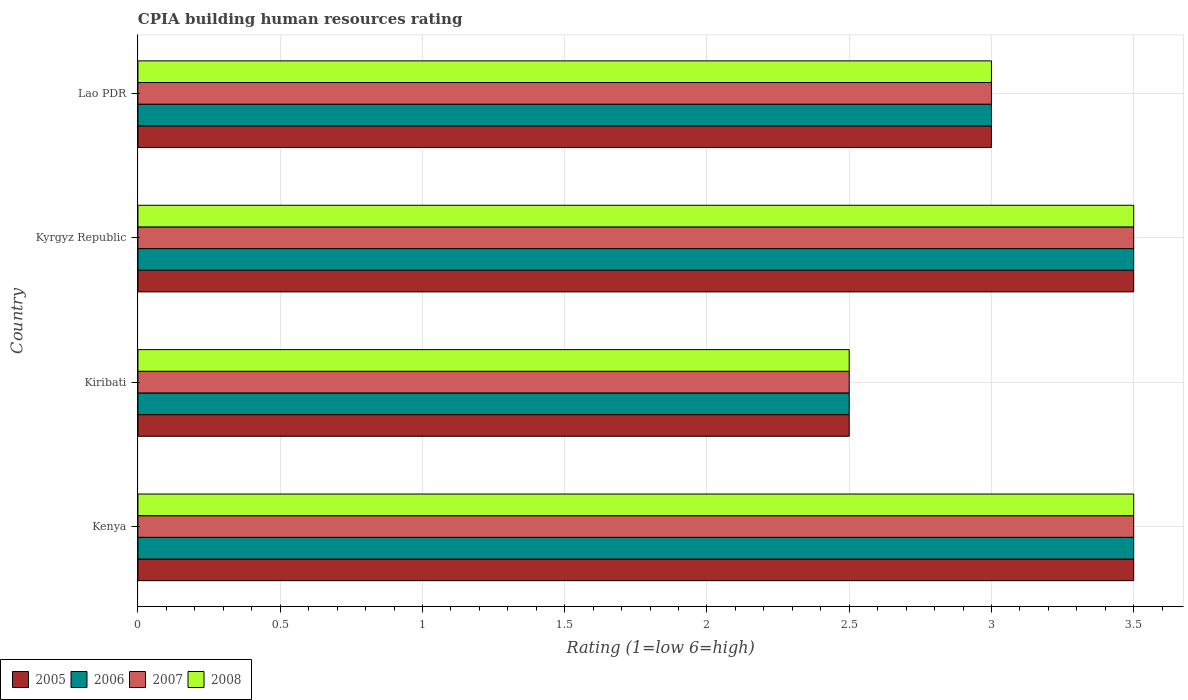How many groups of bars are there?
Provide a short and direct response. 4. Are the number of bars on each tick of the Y-axis equal?
Your answer should be compact. Yes. How many bars are there on the 2nd tick from the top?
Offer a terse response. 4. What is the label of the 2nd group of bars from the top?
Offer a terse response. Kyrgyz Republic. In how many cases, is the number of bars for a given country not equal to the number of legend labels?
Offer a very short reply. 0. Across all countries, what is the maximum CPIA rating in 2008?
Offer a very short reply. 3.5. Across all countries, what is the minimum CPIA rating in 2007?
Offer a terse response. 2.5. In which country was the CPIA rating in 2007 maximum?
Give a very brief answer. Kenya. In which country was the CPIA rating in 2008 minimum?
Offer a terse response. Kiribati. What is the difference between the CPIA rating in 2005 in Kenya and the CPIA rating in 2008 in Kiribati?
Ensure brevity in your answer.  1. What is the average CPIA rating in 2006 per country?
Provide a succinct answer. 3.12. In how many countries, is the CPIA rating in 2008 greater than 0.7 ?
Ensure brevity in your answer.  4. What is the ratio of the CPIA rating in 2005 in Kenya to that in Kiribati?
Your answer should be very brief. 1.4. Is the CPIA rating in 2008 in Kyrgyz Republic less than that in Lao PDR?
Make the answer very short. No. Is the difference between the CPIA rating in 2006 in Kenya and Kyrgyz Republic greater than the difference between the CPIA rating in 2008 in Kenya and Kyrgyz Republic?
Offer a very short reply. No. What is the difference between the highest and the second highest CPIA rating in 2005?
Offer a terse response. 0. What is the difference between the highest and the lowest CPIA rating in 2005?
Ensure brevity in your answer.  1. What does the 2nd bar from the top in Kiribati represents?
Make the answer very short. 2007. What does the 4th bar from the bottom in Lao PDR represents?
Your response must be concise. 2008. How many bars are there?
Provide a short and direct response. 16. What is the title of the graph?
Your answer should be compact. CPIA building human resources rating. What is the label or title of the Y-axis?
Offer a very short reply. Country. What is the Rating (1=low 6=high) of 2005 in Kenya?
Give a very brief answer. 3.5. What is the Rating (1=low 6=high) in 2006 in Kenya?
Offer a terse response. 3.5. What is the Rating (1=low 6=high) in 2007 in Kenya?
Your answer should be compact. 3.5. What is the Rating (1=low 6=high) of 2008 in Kyrgyz Republic?
Keep it short and to the point. 3.5. What is the Rating (1=low 6=high) in 2005 in Lao PDR?
Ensure brevity in your answer.  3. Across all countries, what is the maximum Rating (1=low 6=high) of 2007?
Your answer should be compact. 3.5. Across all countries, what is the maximum Rating (1=low 6=high) in 2008?
Provide a succinct answer. 3.5. Across all countries, what is the minimum Rating (1=low 6=high) of 2005?
Make the answer very short. 2.5. Across all countries, what is the minimum Rating (1=low 6=high) in 2008?
Make the answer very short. 2.5. What is the total Rating (1=low 6=high) in 2005 in the graph?
Give a very brief answer. 12.5. What is the total Rating (1=low 6=high) in 2006 in the graph?
Provide a succinct answer. 12.5. What is the total Rating (1=low 6=high) in 2007 in the graph?
Ensure brevity in your answer.  12.5. What is the difference between the Rating (1=low 6=high) of 2005 in Kenya and that in Kiribati?
Give a very brief answer. 1. What is the difference between the Rating (1=low 6=high) of 2006 in Kenya and that in Kiribati?
Give a very brief answer. 1. What is the difference between the Rating (1=low 6=high) in 2007 in Kenya and that in Kiribati?
Your answer should be very brief. 1. What is the difference between the Rating (1=low 6=high) of 2008 in Kenya and that in Kiribati?
Keep it short and to the point. 1. What is the difference between the Rating (1=low 6=high) of 2005 in Kenya and that in Kyrgyz Republic?
Offer a very short reply. 0. What is the difference between the Rating (1=low 6=high) in 2007 in Kenya and that in Kyrgyz Republic?
Provide a succinct answer. 0. What is the difference between the Rating (1=low 6=high) of 2008 in Kenya and that in Kyrgyz Republic?
Ensure brevity in your answer.  0. What is the difference between the Rating (1=low 6=high) in 2005 in Kenya and that in Lao PDR?
Offer a terse response. 0.5. What is the difference between the Rating (1=low 6=high) in 2005 in Kiribati and that in Kyrgyz Republic?
Offer a terse response. -1. What is the difference between the Rating (1=low 6=high) of 2006 in Kiribati and that in Kyrgyz Republic?
Your answer should be very brief. -1. What is the difference between the Rating (1=low 6=high) in 2008 in Kiribati and that in Kyrgyz Republic?
Ensure brevity in your answer.  -1. What is the difference between the Rating (1=low 6=high) in 2005 in Kiribati and that in Lao PDR?
Give a very brief answer. -0.5. What is the difference between the Rating (1=low 6=high) in 2006 in Kiribati and that in Lao PDR?
Your response must be concise. -0.5. What is the difference between the Rating (1=low 6=high) in 2008 in Kiribati and that in Lao PDR?
Keep it short and to the point. -0.5. What is the difference between the Rating (1=low 6=high) in 2005 in Kyrgyz Republic and that in Lao PDR?
Ensure brevity in your answer.  0.5. What is the difference between the Rating (1=low 6=high) of 2006 in Kyrgyz Republic and that in Lao PDR?
Your response must be concise. 0.5. What is the difference between the Rating (1=low 6=high) of 2007 in Kyrgyz Republic and that in Lao PDR?
Give a very brief answer. 0.5. What is the difference between the Rating (1=low 6=high) in 2005 in Kenya and the Rating (1=low 6=high) in 2008 in Kyrgyz Republic?
Keep it short and to the point. 0. What is the difference between the Rating (1=low 6=high) in 2006 in Kenya and the Rating (1=low 6=high) in 2007 in Kyrgyz Republic?
Your response must be concise. 0. What is the difference between the Rating (1=low 6=high) of 2005 in Kenya and the Rating (1=low 6=high) of 2006 in Lao PDR?
Ensure brevity in your answer.  0.5. What is the difference between the Rating (1=low 6=high) in 2005 in Kenya and the Rating (1=low 6=high) in 2008 in Lao PDR?
Your answer should be very brief. 0.5. What is the difference between the Rating (1=low 6=high) in 2007 in Kiribati and the Rating (1=low 6=high) in 2008 in Kyrgyz Republic?
Give a very brief answer. -1. What is the difference between the Rating (1=low 6=high) in 2005 in Kiribati and the Rating (1=low 6=high) in 2006 in Lao PDR?
Ensure brevity in your answer.  -0.5. What is the difference between the Rating (1=low 6=high) of 2005 in Kiribati and the Rating (1=low 6=high) of 2007 in Lao PDR?
Offer a terse response. -0.5. What is the difference between the Rating (1=low 6=high) in 2006 in Kiribati and the Rating (1=low 6=high) in 2008 in Lao PDR?
Your response must be concise. -0.5. What is the difference between the Rating (1=low 6=high) in 2007 in Kiribati and the Rating (1=low 6=high) in 2008 in Lao PDR?
Offer a terse response. -0.5. What is the difference between the Rating (1=low 6=high) in 2007 in Kyrgyz Republic and the Rating (1=low 6=high) in 2008 in Lao PDR?
Make the answer very short. 0.5. What is the average Rating (1=low 6=high) in 2005 per country?
Your response must be concise. 3.12. What is the average Rating (1=low 6=high) of 2006 per country?
Your answer should be very brief. 3.12. What is the average Rating (1=low 6=high) of 2007 per country?
Provide a short and direct response. 3.12. What is the average Rating (1=low 6=high) of 2008 per country?
Ensure brevity in your answer.  3.12. What is the difference between the Rating (1=low 6=high) of 2005 and Rating (1=low 6=high) of 2006 in Kenya?
Your answer should be compact. 0. What is the difference between the Rating (1=low 6=high) in 2006 and Rating (1=low 6=high) in 2007 in Kenya?
Your response must be concise. 0. What is the difference between the Rating (1=low 6=high) of 2005 and Rating (1=low 6=high) of 2008 in Kiribati?
Your answer should be compact. 0. What is the difference between the Rating (1=low 6=high) of 2006 and Rating (1=low 6=high) of 2007 in Kiribati?
Your response must be concise. 0. What is the difference between the Rating (1=low 6=high) of 2007 and Rating (1=low 6=high) of 2008 in Kiribati?
Provide a short and direct response. 0. What is the difference between the Rating (1=low 6=high) in 2005 and Rating (1=low 6=high) in 2006 in Kyrgyz Republic?
Ensure brevity in your answer.  0. What is the difference between the Rating (1=low 6=high) of 2007 and Rating (1=low 6=high) of 2008 in Kyrgyz Republic?
Give a very brief answer. 0. What is the difference between the Rating (1=low 6=high) of 2005 and Rating (1=low 6=high) of 2006 in Lao PDR?
Ensure brevity in your answer.  0. What is the difference between the Rating (1=low 6=high) in 2005 and Rating (1=low 6=high) in 2007 in Lao PDR?
Keep it short and to the point. 0. What is the difference between the Rating (1=low 6=high) in 2005 and Rating (1=low 6=high) in 2008 in Lao PDR?
Your response must be concise. 0. What is the difference between the Rating (1=low 6=high) in 2006 and Rating (1=low 6=high) in 2007 in Lao PDR?
Offer a terse response. 0. What is the difference between the Rating (1=low 6=high) of 2006 and Rating (1=low 6=high) of 2008 in Lao PDR?
Your response must be concise. 0. What is the ratio of the Rating (1=low 6=high) in 2005 in Kenya to that in Kiribati?
Give a very brief answer. 1.4. What is the ratio of the Rating (1=low 6=high) in 2006 in Kenya to that in Kiribati?
Provide a short and direct response. 1.4. What is the ratio of the Rating (1=low 6=high) of 2008 in Kenya to that in Kiribati?
Offer a terse response. 1.4. What is the ratio of the Rating (1=low 6=high) of 2005 in Kenya to that in Kyrgyz Republic?
Your answer should be compact. 1. What is the ratio of the Rating (1=low 6=high) in 2006 in Kenya to that in Kyrgyz Republic?
Provide a short and direct response. 1. What is the ratio of the Rating (1=low 6=high) in 2008 in Kenya to that in Kyrgyz Republic?
Your answer should be compact. 1. What is the ratio of the Rating (1=low 6=high) in 2005 in Kenya to that in Lao PDR?
Your response must be concise. 1.17. What is the ratio of the Rating (1=low 6=high) of 2006 in Kenya to that in Lao PDR?
Keep it short and to the point. 1.17. What is the ratio of the Rating (1=low 6=high) of 2007 in Kenya to that in Lao PDR?
Offer a terse response. 1.17. What is the ratio of the Rating (1=low 6=high) of 2005 in Kiribati to that in Kyrgyz Republic?
Offer a very short reply. 0.71. What is the ratio of the Rating (1=low 6=high) in 2006 in Kiribati to that in Kyrgyz Republic?
Offer a terse response. 0.71. What is the ratio of the Rating (1=low 6=high) in 2007 in Kiribati to that in Kyrgyz Republic?
Offer a terse response. 0.71. What is the ratio of the Rating (1=low 6=high) of 2008 in Kiribati to that in Kyrgyz Republic?
Your answer should be compact. 0.71. What is the ratio of the Rating (1=low 6=high) of 2005 in Kiribati to that in Lao PDR?
Your answer should be compact. 0.83. What is the ratio of the Rating (1=low 6=high) of 2006 in Kiribati to that in Lao PDR?
Offer a terse response. 0.83. What is the ratio of the Rating (1=low 6=high) in 2008 in Kiribati to that in Lao PDR?
Ensure brevity in your answer.  0.83. What is the ratio of the Rating (1=low 6=high) of 2005 in Kyrgyz Republic to that in Lao PDR?
Offer a terse response. 1.17. What is the ratio of the Rating (1=low 6=high) in 2008 in Kyrgyz Republic to that in Lao PDR?
Provide a short and direct response. 1.17. What is the difference between the highest and the second highest Rating (1=low 6=high) of 2006?
Offer a terse response. 0. What is the difference between the highest and the second highest Rating (1=low 6=high) of 2007?
Provide a succinct answer. 0. What is the difference between the highest and the lowest Rating (1=low 6=high) in 2005?
Make the answer very short. 1. What is the difference between the highest and the lowest Rating (1=low 6=high) in 2006?
Offer a terse response. 1. What is the difference between the highest and the lowest Rating (1=low 6=high) of 2007?
Your answer should be very brief. 1. What is the difference between the highest and the lowest Rating (1=low 6=high) of 2008?
Make the answer very short. 1. 